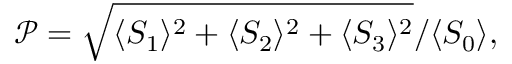Convert formula to latex. <formula><loc_0><loc_0><loc_500><loc_500>\mathcal { P } = { \sqrt { \langle S _ { 1 } \rangle ^ { 2 } + \langle S _ { 2 } \rangle ^ { 2 } + \langle S _ { 3 } \rangle ^ { 2 } } } / { \langle S _ { 0 } \rangle } ,</formula> 